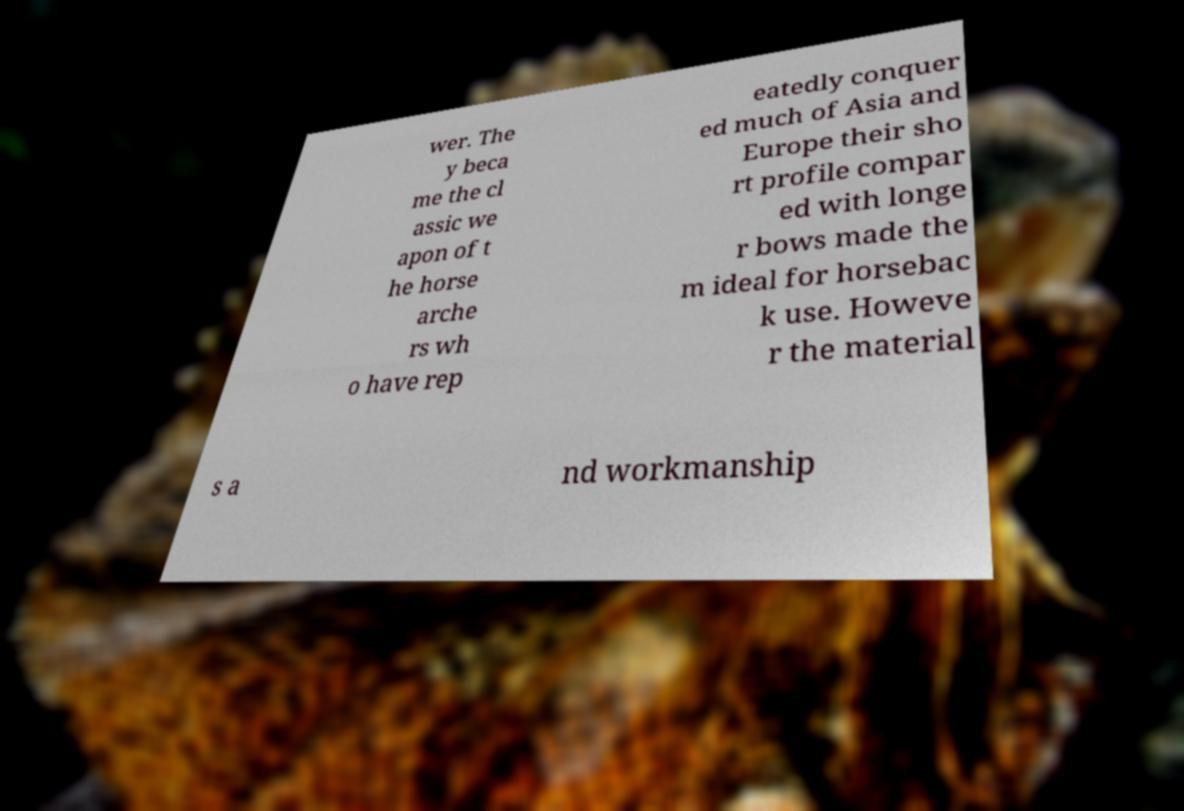Please identify and transcribe the text found in this image. wer. The y beca me the cl assic we apon of t he horse arche rs wh o have rep eatedly conquer ed much of Asia and Europe their sho rt profile compar ed with longe r bows made the m ideal for horsebac k use. Howeve r the material s a nd workmanship 